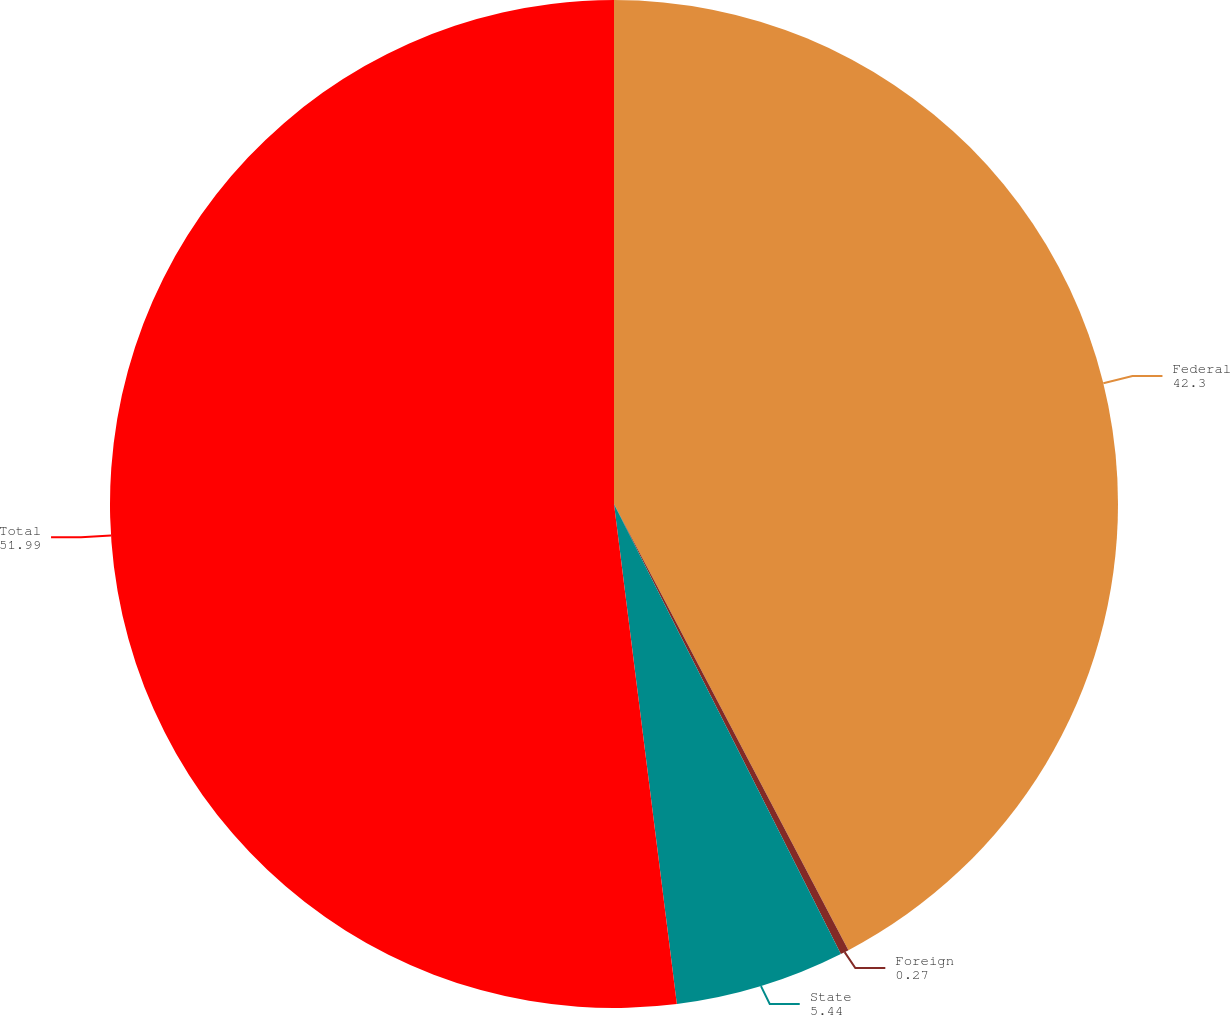Convert chart to OTSL. <chart><loc_0><loc_0><loc_500><loc_500><pie_chart><fcel>Federal<fcel>Foreign<fcel>State<fcel>Total<nl><fcel>42.3%<fcel>0.27%<fcel>5.44%<fcel>51.99%<nl></chart> 